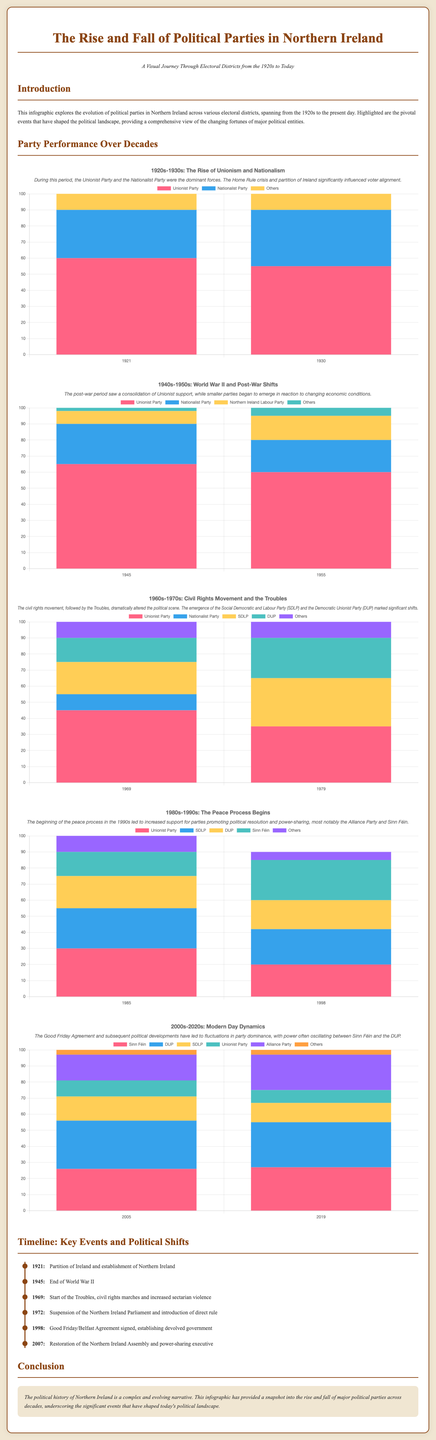What year was the Partition of Ireland? The timeline in the document specifies that the Partition of Ireland occurred in 1921.
Answer: 1921 Which political party emerged prominently during the civil rights movement of the 1960s? The chart highlights the emergence of the Social Democratic and Labour Party (SDLP) during the civil rights movement in the 1960s.
Answer: SDLP What percentage of the vote did the Unionist Party receive in 1945? According to the data, the Unionist Party received 65% of the vote in 1945.
Answer: 65% When was the Good Friday Agreement signed? The timeline indicates that the Good Friday Agreement was signed in 1998.
Answer: 1998 Which two parties had the highest percentages in the 2019 election? The chart shows that Sinn Féin and the Democratic Unionist Party had the highest percentages in 2019, with 27% and 28% respectively.
Answer: Sinn Féin and DUP What was a key event in 1972? The document states that in 1972, there was a suspension of the Northern Ireland Parliament and introduction of direct rule.
Answer: Suspension of Parliament Which decade saw the rise of Sinn Féin among voters? The visual data suggests that Sinn Féin's rise among voters was particularly notable in the 2000s-2020s as indicated in that section of the document.
Answer: 2000s-2020s How many parties are represented in the 1985 chart? The chart for 1985 indicates that four parties are represented: Unionist Party, SDLP, DUP, and Sinn Féin.
Answer: Four What type of chart is used for presenting party performance? The document specifies that stacked bar charts are used to represent party performance over different decades.
Answer: Stacked bar charts 